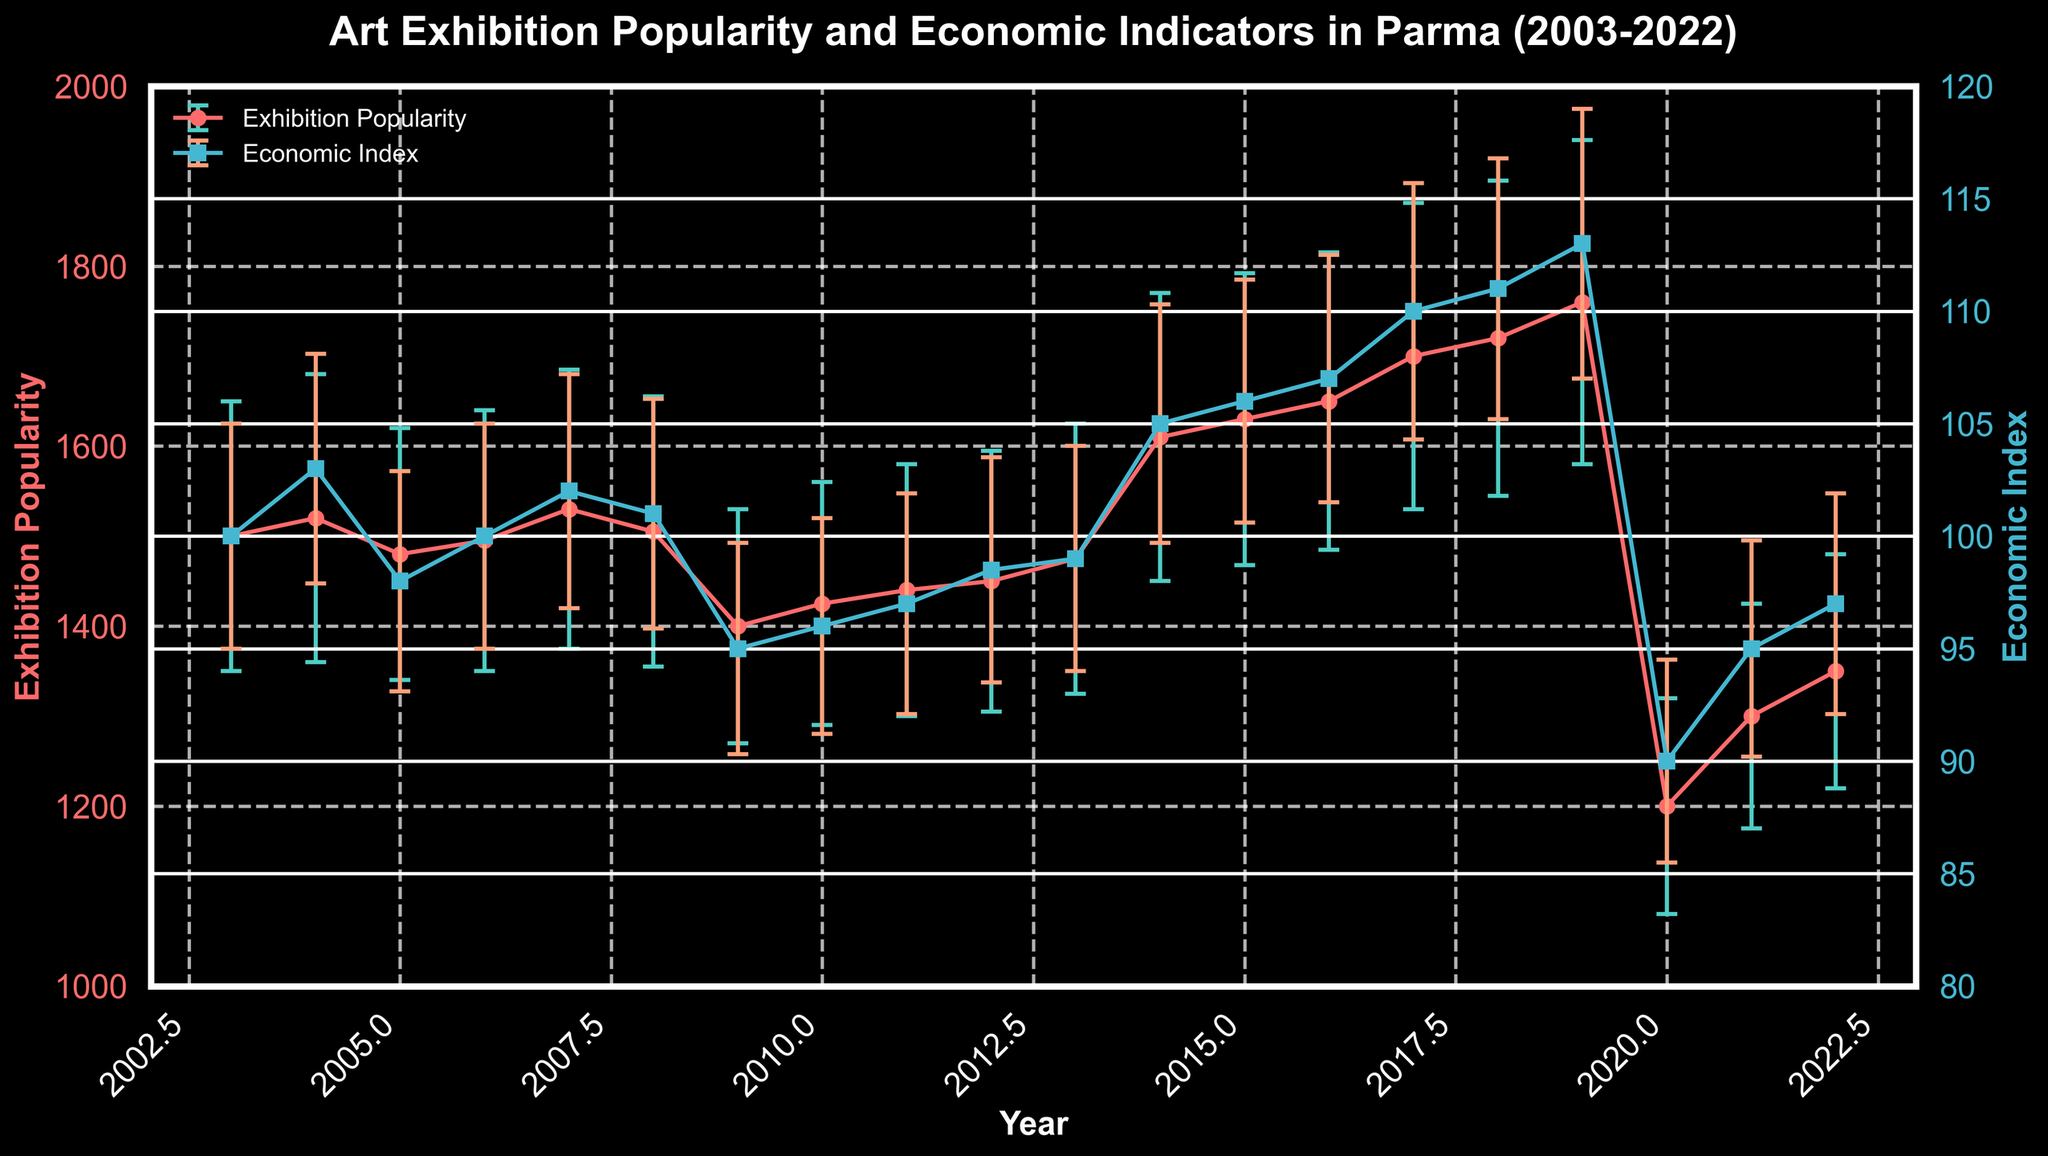What's the title of the figure? The title is prominently displayed above the plot. It reads "Art Exhibition Popularity and Economic Indicators in Parma (2003-2022)."
Answer: Art Exhibition Popularity and Economic Indicators in Parma (2003-2022) What is the peak value of Exhibition Popularity, and in which year does it occur? The highest point in the Exhibition Popularity line is around 1760, which occurs in the year 2019.
Answer: 1760 in 2019 Which year has the lowest Economic Index, and what is its value? The lowest Economic Index value is approximately 90, which occurs in the year 2020.
Answer: 90 in 2020 What is the trend of Exhibition Popularity between 2003 and 2022? The Exhibition Popularity shows a general upward trend from 2003 to 2019, then a significant drop in 2020, and a slight recovery in 2021 and 2022.
Answer: General upward trend with a drop in 2020 How do the economic indicators compare between 2009 and 2010? In 2009, the Economic Index is 95, while in 2010, it is 96. The economic situation improved slightly from 2009 to 2010.
Answer: Improved from 95 to 96 What can be inferred about the relationship between Economic Index and Exhibition Popularity in 2020? Both the Economic Index and Exhibition Popularity drop significantly in 2020, indicating a possible correlation between the economic downturn and reduced popularity of art exhibitions.
Answer: Both dropped significantly In which period is the Economic Index the highest, and what is its corresponding value? The highest Economic Index, approximately 113, occurs in the year 2019.
Answer: 113 in 2019 How does the error margin of Economic Index in 2018 compare to that of Exhibition Popularity in the same year? The error margin for Economic Index in 2018 is 5.8, whereas for Exhibition Popularity it is 175. The error margin for Exhibition Popularity is significantly larger than that of the Economic Index.
Answer: Higher for Exhibition Popularity What happens to Exhibition Popularity after 2019? Exhibition Popularity drops significantly in 2020 and then begins to recover in 2021 and 2022.
Answer: Drops and then recovers 